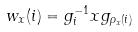<formula> <loc_0><loc_0><loc_500><loc_500>w _ { x } ( i ) = g _ { i } ^ { - 1 } x g _ { \rho _ { x } ( i ) }</formula> 